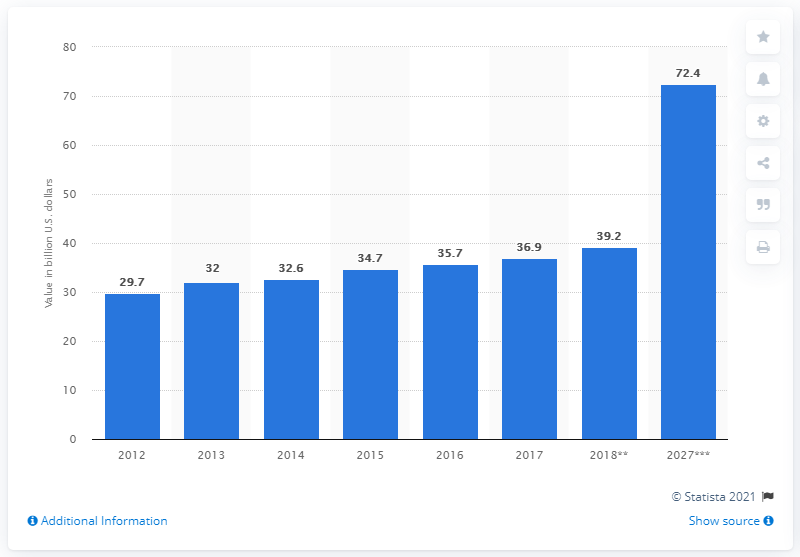Specify some key components in this picture. In 2012, domestic expenditure in travel and tourism contributed to the Gulf Cooperation Council. By 2028, it is projected that domestic expenditure in travel and tourism will contribute a significant amount to the GDP of the Gulf Cooperation Council (GCC) countries, estimated to be 72.4%. 